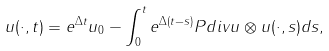<formula> <loc_0><loc_0><loc_500><loc_500>u ( \cdot , t ) = e ^ { \Delta t } u _ { 0 } - \int _ { 0 } ^ { t } e ^ { \Delta ( t - s ) } P d i v u \otimes u ( \cdot , s ) d s ,</formula> 